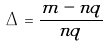Convert formula to latex. <formula><loc_0><loc_0><loc_500><loc_500>\Delta = \frac { m - n q } { n q }</formula> 